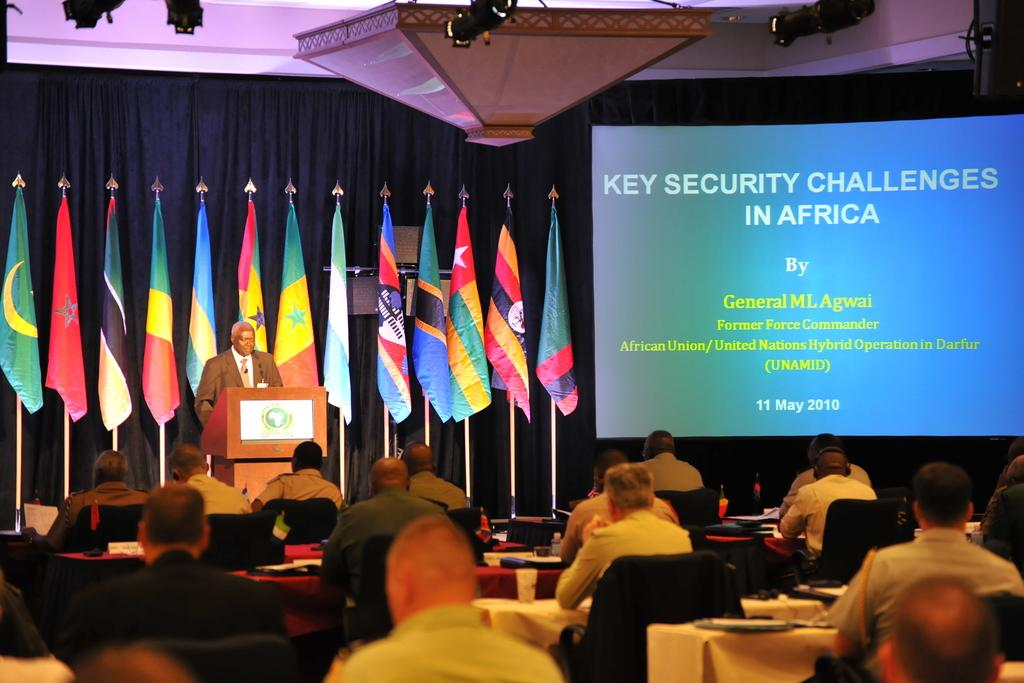How many people are in the image? There is a group of people in the image. What are the people doing in the image? The people are sitting on chairs. Who is standing in the image? There is a man standing at a podium. What can be seen in the background of the image? There are flags, a screen, and curtains in the background of the image. What type of fruit is being passed around by the people in the image? There is no fruit present in the image; the people are sitting on chairs and the man is standing at a podium. How does the pest affect the connection between the people in the image? There is no mention of a pest or a connection between the people in the image. 